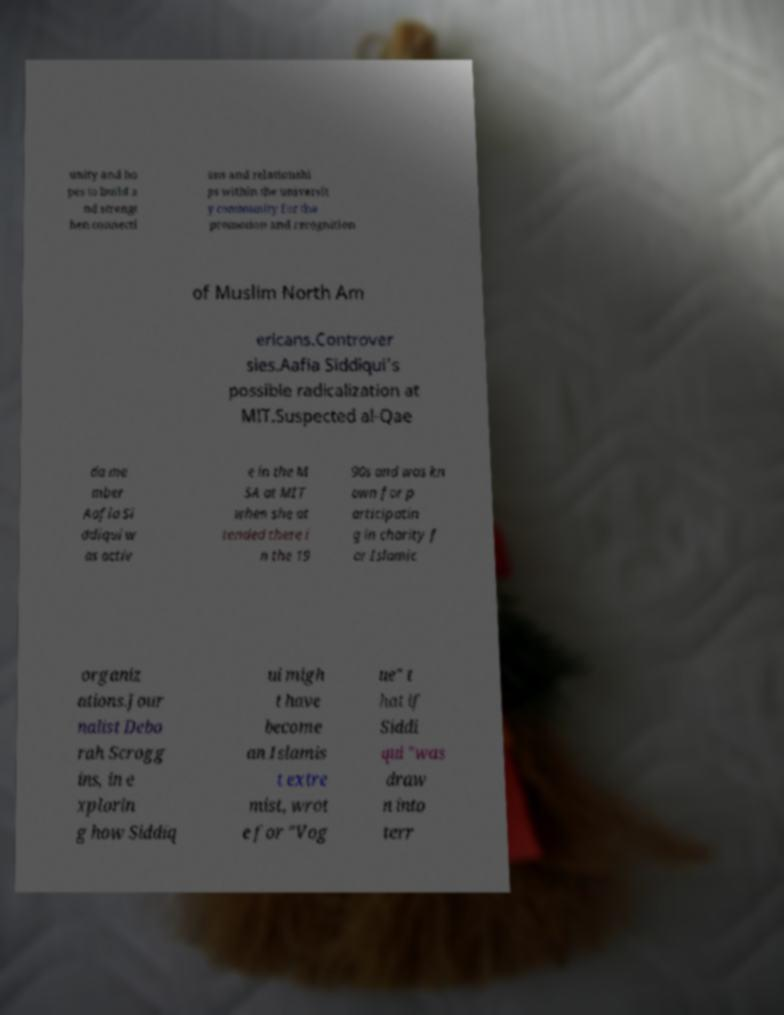What messages or text are displayed in this image? I need them in a readable, typed format. unity and ho pes to build a nd strengt hen connecti ons and relationshi ps within the universit y community for the promotion and recognition of Muslim North Am ericans.Controver sies.Aafia Siddiqui's possible radicalization at MIT.Suspected al-Qae da me mber Aafia Si ddiqui w as activ e in the M SA at MIT when she at tended there i n the 19 90s and was kn own for p articipatin g in charity f or Islamic organiz ations.Jour nalist Debo rah Scrogg ins, in e xplorin g how Siddiq ui migh t have become an Islamis t extre mist, wrot e for "Vog ue" t hat if Siddi qui "was draw n into terr 